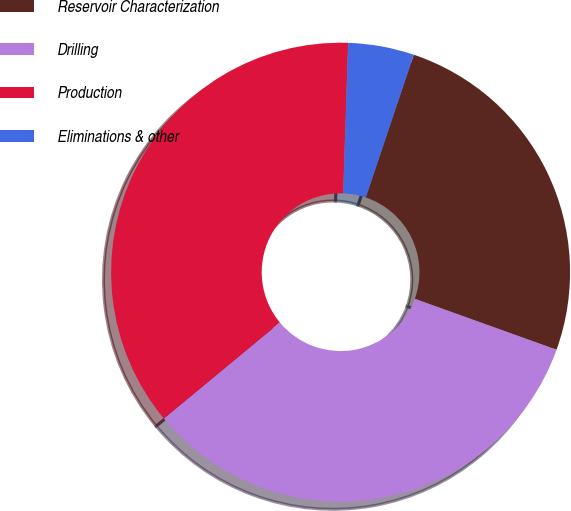Convert chart to OTSL. <chart><loc_0><loc_0><loc_500><loc_500><pie_chart><fcel>Reservoir Characterization<fcel>Drilling<fcel>Production<fcel>Eliminations & other<nl><fcel>25.32%<fcel>33.51%<fcel>36.53%<fcel>4.64%<nl></chart> 